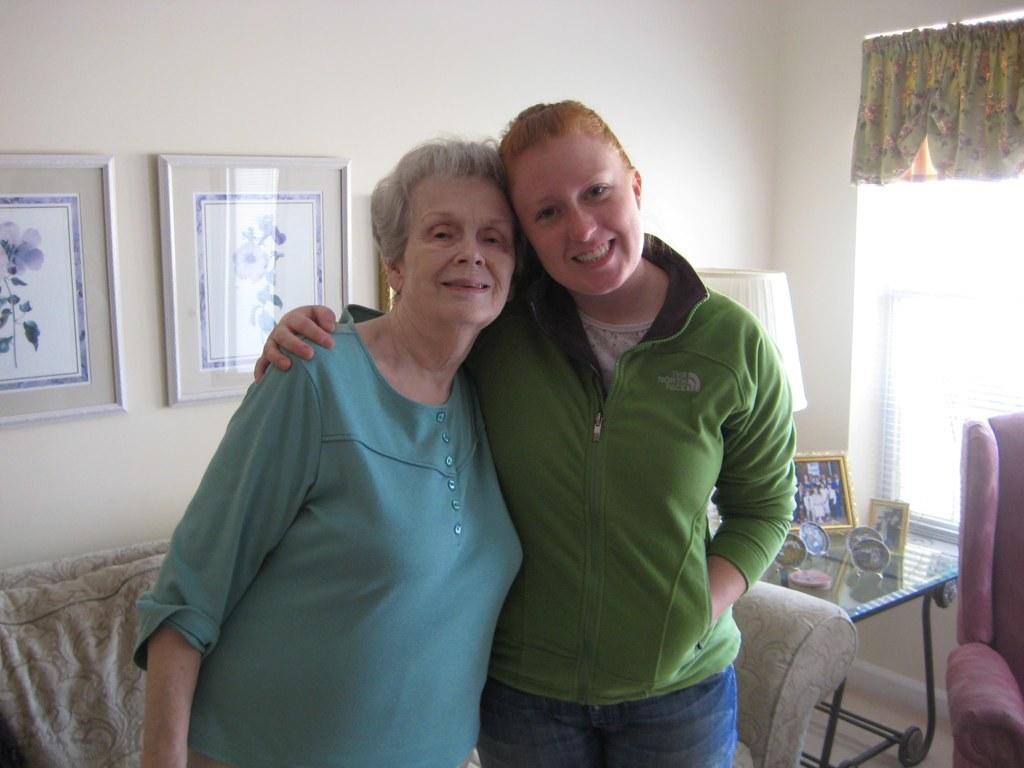Describe this image in one or two sentences. In the picture we can see a old woman and a woman standing, a old woman is wearing a blue T-shirt and woman is wearing a green T-shirt. In the background we can see a sofa which is white in color and next to it there is a table and some things kept on it with a lamp and we can also see the window with the curtain, and a wall with photo frames. 